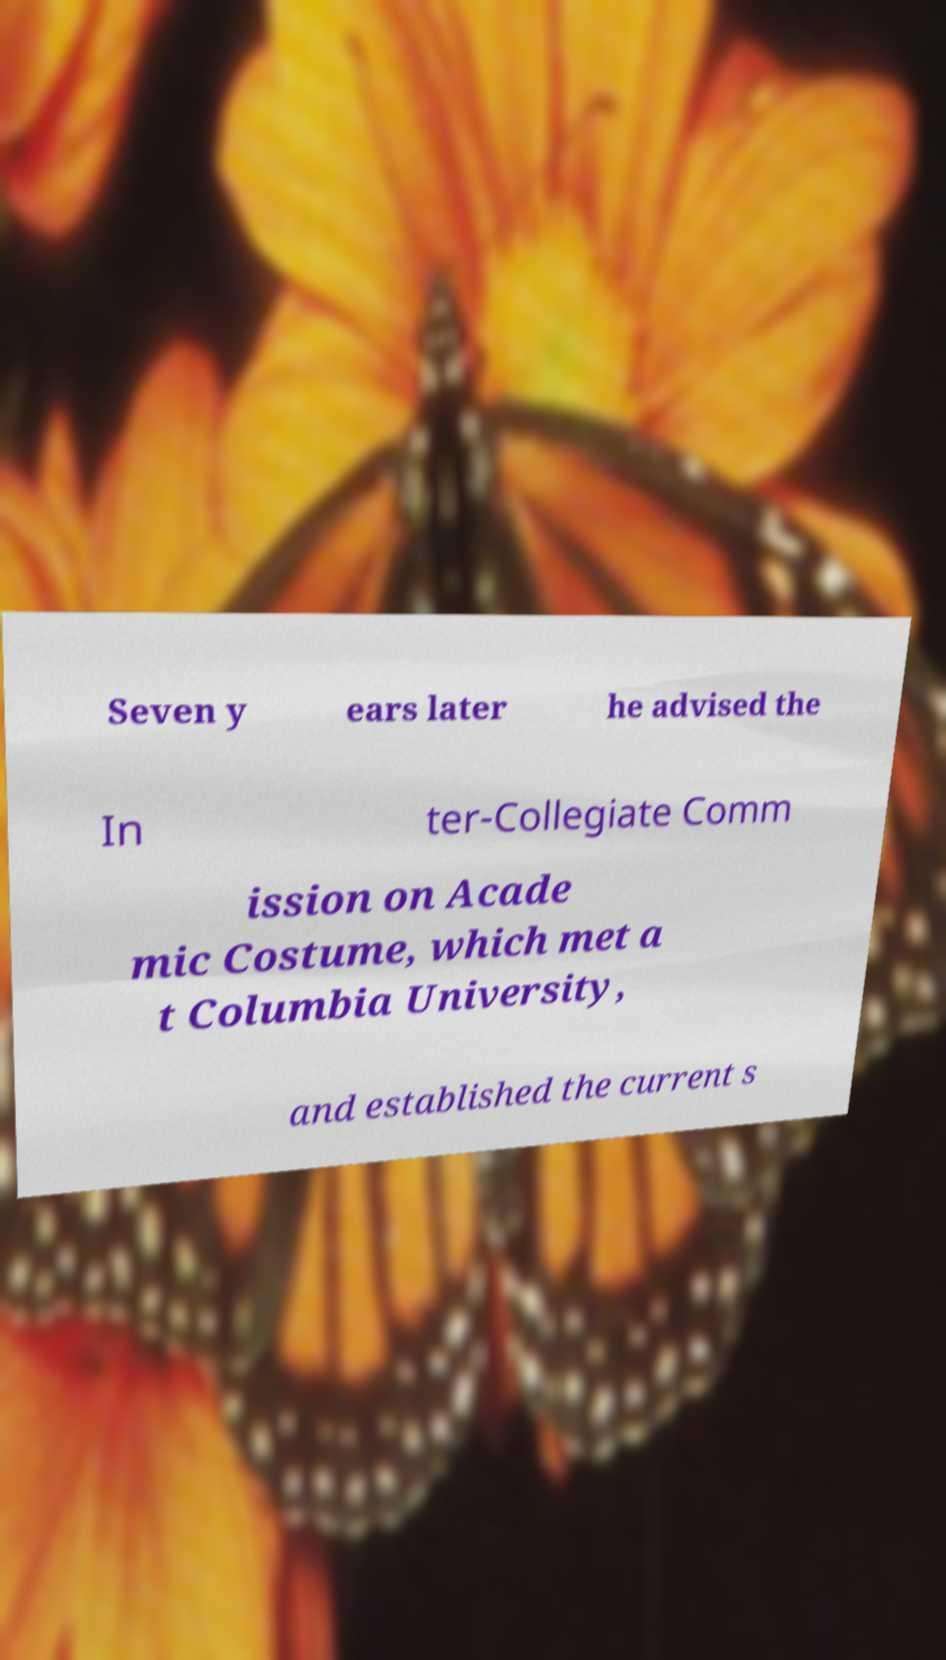Please read and relay the text visible in this image. What does it say? Seven y ears later he advised the In ter-Collegiate Comm ission on Acade mic Costume, which met a t Columbia University, and established the current s 